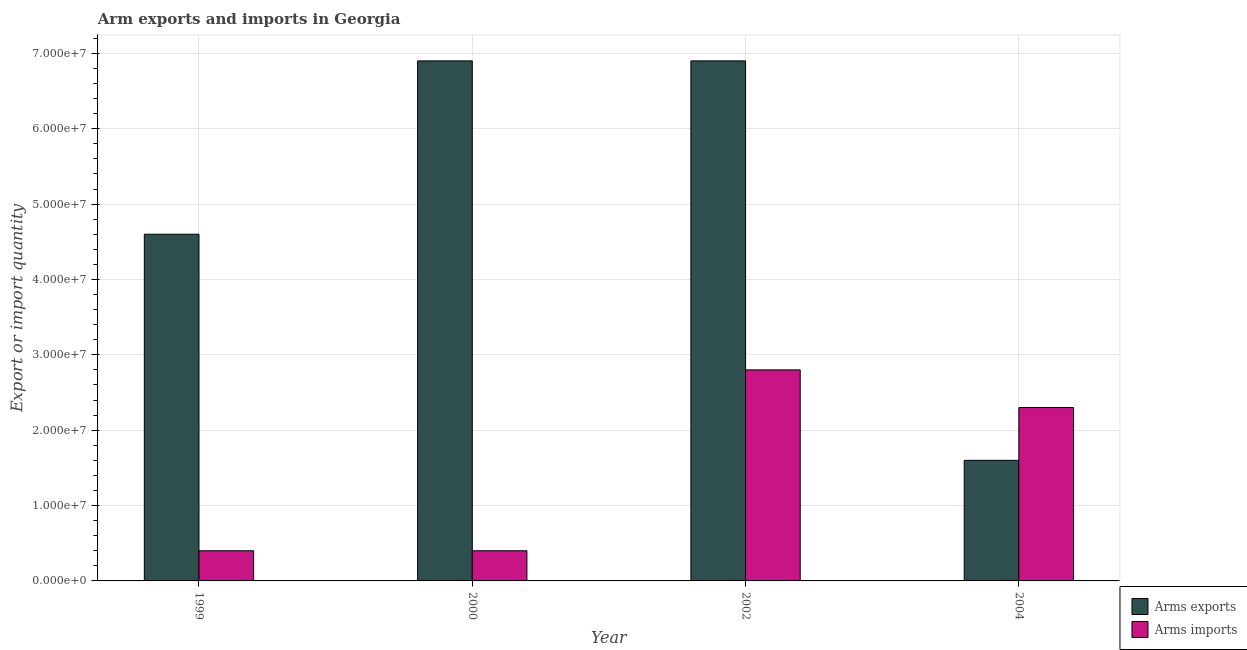How many groups of bars are there?
Provide a short and direct response. 4. Are the number of bars per tick equal to the number of legend labels?
Offer a very short reply. Yes. Are the number of bars on each tick of the X-axis equal?
Your answer should be very brief. Yes. How many bars are there on the 3rd tick from the right?
Provide a succinct answer. 2. What is the arms exports in 2000?
Your answer should be compact. 6.90e+07. Across all years, what is the maximum arms imports?
Make the answer very short. 2.80e+07. Across all years, what is the minimum arms imports?
Your response must be concise. 4.00e+06. In which year was the arms imports minimum?
Offer a terse response. 1999. What is the total arms exports in the graph?
Provide a short and direct response. 2.00e+08. What is the difference between the arms imports in 2000 and that in 2002?
Offer a very short reply. -2.40e+07. In how many years, is the arms exports greater than 56000000?
Make the answer very short. 2. What is the ratio of the arms imports in 1999 to that in 2004?
Your answer should be very brief. 0.17. Is the difference between the arms exports in 2000 and 2002 greater than the difference between the arms imports in 2000 and 2002?
Make the answer very short. No. What is the difference between the highest and the lowest arms imports?
Your response must be concise. 2.40e+07. In how many years, is the arms exports greater than the average arms exports taken over all years?
Your answer should be compact. 2. Is the sum of the arms imports in 2002 and 2004 greater than the maximum arms exports across all years?
Provide a succinct answer. Yes. What does the 1st bar from the left in 2004 represents?
Offer a very short reply. Arms exports. What does the 1st bar from the right in 2004 represents?
Your answer should be compact. Arms imports. How many bars are there?
Provide a succinct answer. 8. How many years are there in the graph?
Offer a very short reply. 4. What is the difference between two consecutive major ticks on the Y-axis?
Offer a very short reply. 1.00e+07. Are the values on the major ticks of Y-axis written in scientific E-notation?
Make the answer very short. Yes. Does the graph contain any zero values?
Offer a terse response. No. What is the title of the graph?
Give a very brief answer. Arm exports and imports in Georgia. Does "Tetanus" appear as one of the legend labels in the graph?
Give a very brief answer. No. What is the label or title of the Y-axis?
Your answer should be compact. Export or import quantity. What is the Export or import quantity of Arms exports in 1999?
Your response must be concise. 4.60e+07. What is the Export or import quantity of Arms exports in 2000?
Offer a terse response. 6.90e+07. What is the Export or import quantity in Arms imports in 2000?
Offer a terse response. 4.00e+06. What is the Export or import quantity in Arms exports in 2002?
Keep it short and to the point. 6.90e+07. What is the Export or import quantity of Arms imports in 2002?
Provide a short and direct response. 2.80e+07. What is the Export or import quantity in Arms exports in 2004?
Offer a very short reply. 1.60e+07. What is the Export or import quantity of Arms imports in 2004?
Your response must be concise. 2.30e+07. Across all years, what is the maximum Export or import quantity of Arms exports?
Your response must be concise. 6.90e+07. Across all years, what is the maximum Export or import quantity of Arms imports?
Your answer should be very brief. 2.80e+07. Across all years, what is the minimum Export or import quantity of Arms exports?
Keep it short and to the point. 1.60e+07. What is the total Export or import quantity of Arms imports in the graph?
Offer a terse response. 5.90e+07. What is the difference between the Export or import quantity in Arms exports in 1999 and that in 2000?
Provide a short and direct response. -2.30e+07. What is the difference between the Export or import quantity of Arms exports in 1999 and that in 2002?
Offer a terse response. -2.30e+07. What is the difference between the Export or import quantity in Arms imports in 1999 and that in 2002?
Your response must be concise. -2.40e+07. What is the difference between the Export or import quantity of Arms exports in 1999 and that in 2004?
Your answer should be very brief. 3.00e+07. What is the difference between the Export or import quantity in Arms imports in 1999 and that in 2004?
Your answer should be very brief. -1.90e+07. What is the difference between the Export or import quantity in Arms exports in 2000 and that in 2002?
Provide a short and direct response. 0. What is the difference between the Export or import quantity of Arms imports in 2000 and that in 2002?
Offer a terse response. -2.40e+07. What is the difference between the Export or import quantity in Arms exports in 2000 and that in 2004?
Offer a very short reply. 5.30e+07. What is the difference between the Export or import quantity of Arms imports in 2000 and that in 2004?
Offer a terse response. -1.90e+07. What is the difference between the Export or import quantity of Arms exports in 2002 and that in 2004?
Ensure brevity in your answer.  5.30e+07. What is the difference between the Export or import quantity in Arms exports in 1999 and the Export or import quantity in Arms imports in 2000?
Your answer should be compact. 4.20e+07. What is the difference between the Export or import quantity of Arms exports in 1999 and the Export or import quantity of Arms imports in 2002?
Offer a very short reply. 1.80e+07. What is the difference between the Export or import quantity of Arms exports in 1999 and the Export or import quantity of Arms imports in 2004?
Make the answer very short. 2.30e+07. What is the difference between the Export or import quantity of Arms exports in 2000 and the Export or import quantity of Arms imports in 2002?
Provide a succinct answer. 4.10e+07. What is the difference between the Export or import quantity of Arms exports in 2000 and the Export or import quantity of Arms imports in 2004?
Your answer should be very brief. 4.60e+07. What is the difference between the Export or import quantity of Arms exports in 2002 and the Export or import quantity of Arms imports in 2004?
Keep it short and to the point. 4.60e+07. What is the average Export or import quantity in Arms exports per year?
Your answer should be very brief. 5.00e+07. What is the average Export or import quantity of Arms imports per year?
Offer a terse response. 1.48e+07. In the year 1999, what is the difference between the Export or import quantity in Arms exports and Export or import quantity in Arms imports?
Keep it short and to the point. 4.20e+07. In the year 2000, what is the difference between the Export or import quantity of Arms exports and Export or import quantity of Arms imports?
Provide a short and direct response. 6.50e+07. In the year 2002, what is the difference between the Export or import quantity of Arms exports and Export or import quantity of Arms imports?
Make the answer very short. 4.10e+07. In the year 2004, what is the difference between the Export or import quantity in Arms exports and Export or import quantity in Arms imports?
Offer a very short reply. -7.00e+06. What is the ratio of the Export or import quantity in Arms imports in 1999 to that in 2000?
Your answer should be compact. 1. What is the ratio of the Export or import quantity of Arms exports in 1999 to that in 2002?
Offer a very short reply. 0.67. What is the ratio of the Export or import quantity in Arms imports in 1999 to that in 2002?
Your answer should be compact. 0.14. What is the ratio of the Export or import quantity of Arms exports in 1999 to that in 2004?
Keep it short and to the point. 2.88. What is the ratio of the Export or import quantity of Arms imports in 1999 to that in 2004?
Offer a very short reply. 0.17. What is the ratio of the Export or import quantity of Arms imports in 2000 to that in 2002?
Your answer should be compact. 0.14. What is the ratio of the Export or import quantity in Arms exports in 2000 to that in 2004?
Your answer should be very brief. 4.31. What is the ratio of the Export or import quantity in Arms imports in 2000 to that in 2004?
Provide a short and direct response. 0.17. What is the ratio of the Export or import quantity in Arms exports in 2002 to that in 2004?
Offer a very short reply. 4.31. What is the ratio of the Export or import quantity in Arms imports in 2002 to that in 2004?
Give a very brief answer. 1.22. What is the difference between the highest and the second highest Export or import quantity in Arms exports?
Make the answer very short. 0. What is the difference between the highest and the second highest Export or import quantity in Arms imports?
Make the answer very short. 5.00e+06. What is the difference between the highest and the lowest Export or import quantity in Arms exports?
Give a very brief answer. 5.30e+07. What is the difference between the highest and the lowest Export or import quantity in Arms imports?
Your response must be concise. 2.40e+07. 